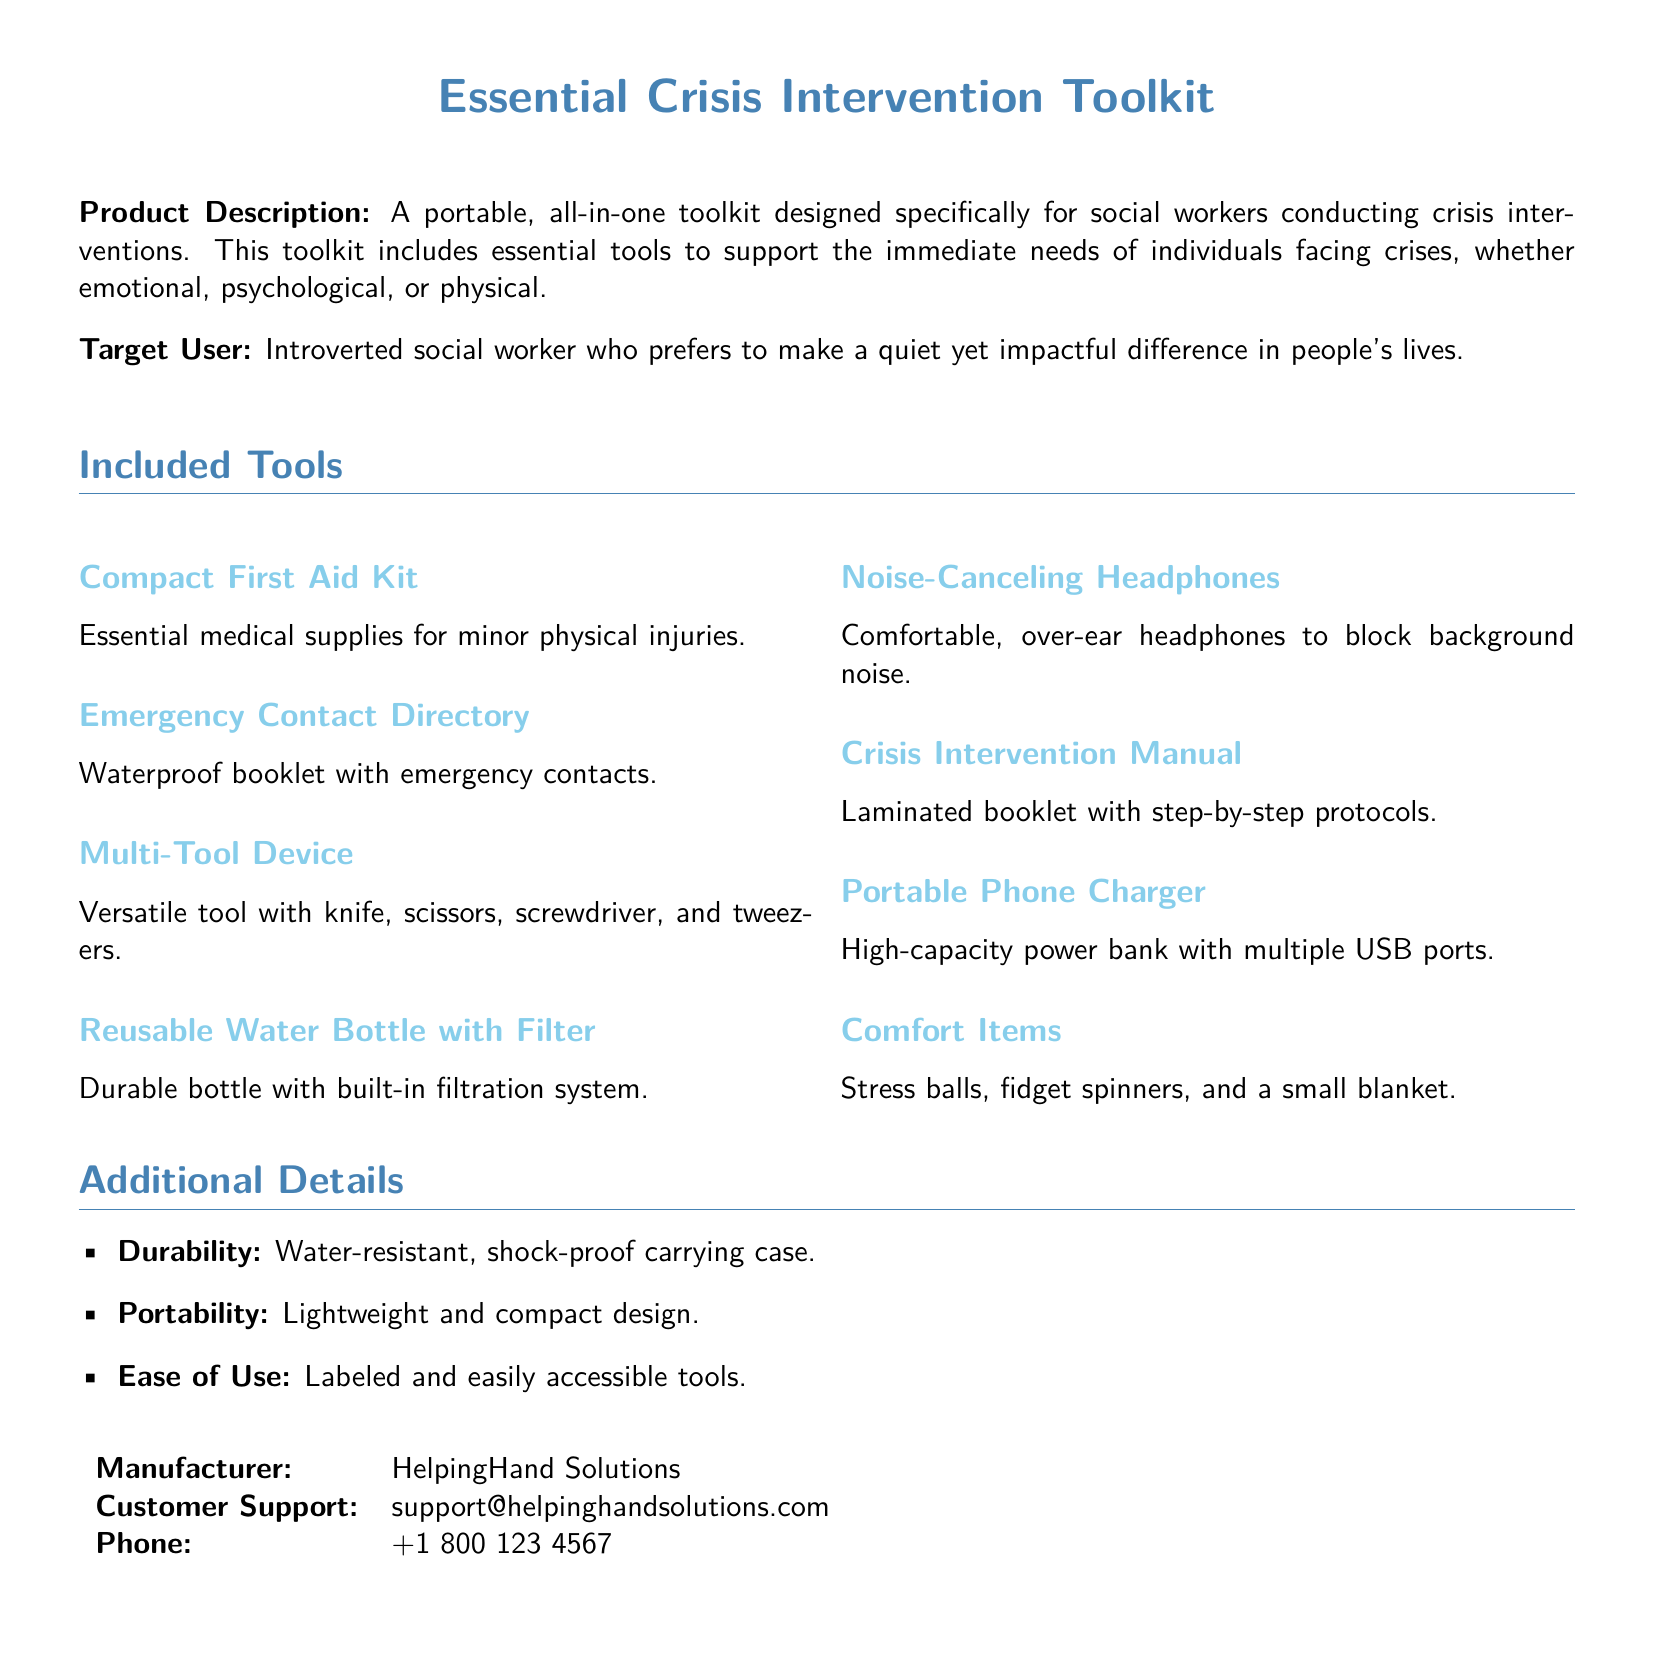What is the product name? The product name is clearly stated at the top of the document as "Essential Crisis Intervention Toolkit."
Answer: Essential Crisis Intervention Toolkit Who is the target user? The target user is identified in the document as the person who would benefit most from the toolkit, which is an introverted social worker.
Answer: Introverted social worker What type of carrying case is mentioned? The document specifies that the carrying case is water-resistant and shock-proof, indicating its durability.
Answer: Water-resistant, shock-proof How many tools are included in the toolkit? The document lists eight different tools in the Included Tools section, signifying the total number.
Answer: Eight What item is designed for noise reduction? The document mentions noise-canceling headphones as a specific item included for reducing background noise.
Answer: Noise-Canceling Headphones Which organization manufactures the toolkit? The manufacturer's name is supplied in the Additional Details section of the document.
Answer: HelpingHand Solutions What is the purpose of the Crisis Intervention Manual? The document states that the manual provides step-by-step protocols for crisis intervention, indicating its intended use.
Answer: Step-by-step protocols What is included in the comfort items? The comfort items section details specific items to help alleviate stress during interventions, which are specified in the document.
Answer: Stress balls, fidget spinners, and a small blanket 